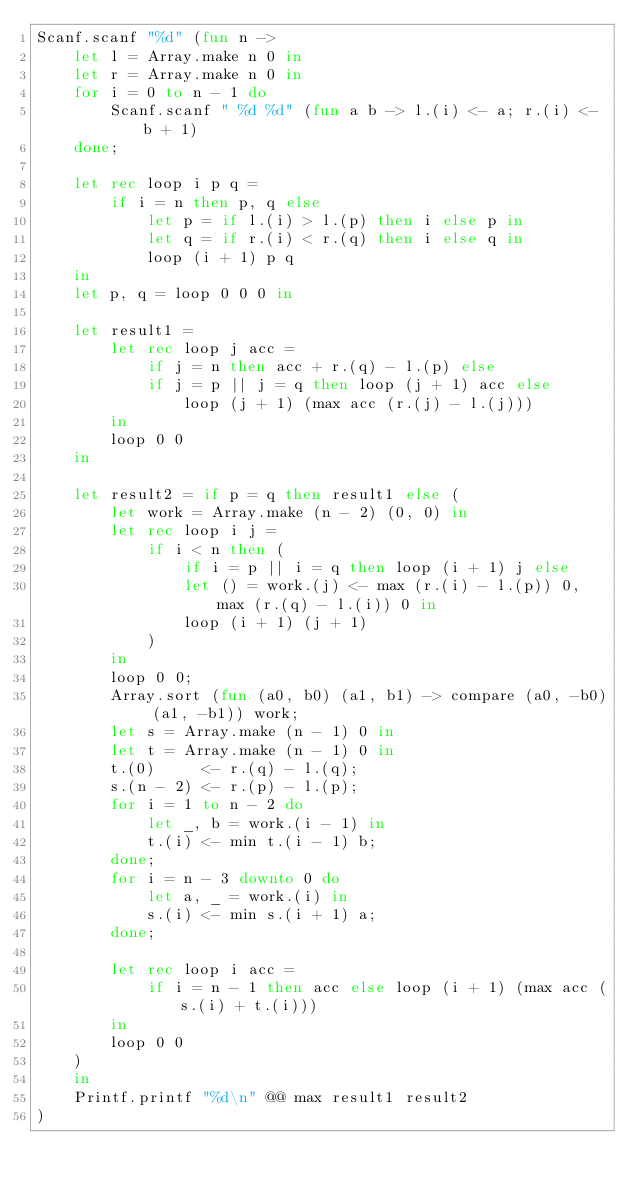<code> <loc_0><loc_0><loc_500><loc_500><_OCaml_>Scanf.scanf "%d" (fun n ->
    let l = Array.make n 0 in
    let r = Array.make n 0 in
    for i = 0 to n - 1 do
        Scanf.scanf " %d %d" (fun a b -> l.(i) <- a; r.(i) <- b + 1)
    done;

    let rec loop i p q =
        if i = n then p, q else
            let p = if l.(i) > l.(p) then i else p in
            let q = if r.(i) < r.(q) then i else q in
            loop (i + 1) p q
    in
    let p, q = loop 0 0 0 in

    let result1 =
        let rec loop j acc =
            if j = n then acc + r.(q) - l.(p) else
            if j = p || j = q then loop (j + 1) acc else
                loop (j + 1) (max acc (r.(j) - l.(j)))
        in
        loop 0 0
    in
 
    let result2 = if p = q then result1 else (
        let work = Array.make (n - 2) (0, 0) in
        let rec loop i j =
            if i < n then (
                if i = p || i = q then loop (i + 1) j else
                let () = work.(j) <- max (r.(i) - l.(p)) 0, max (r.(q) - l.(i)) 0 in
                loop (i + 1) (j + 1)
            )
        in
        loop 0 0;
        Array.sort (fun (a0, b0) (a1, b1) -> compare (a0, -b0) (a1, -b1)) work;
        let s = Array.make (n - 1) 0 in
        let t = Array.make (n - 1) 0 in
        t.(0)     <- r.(q) - l.(q);
        s.(n - 2) <- r.(p) - l.(p);
        for i = 1 to n - 2 do
            let _, b = work.(i - 1) in
            t.(i) <- min t.(i - 1) b;
        done;
        for i = n - 3 downto 0 do
            let a, _ = work.(i) in
            s.(i) <- min s.(i + 1) a;
        done;

        let rec loop i acc =
            if i = n - 1 then acc else loop (i + 1) (max acc (s.(i) + t.(i)))
        in
        loop 0 0
    )
    in
    Printf.printf "%d\n" @@ max result1 result2
)</code> 